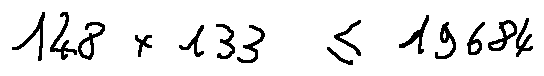<formula> <loc_0><loc_0><loc_500><loc_500>1 4 8 \times 1 3 3 \leq 1 9 6 8 4</formula> 